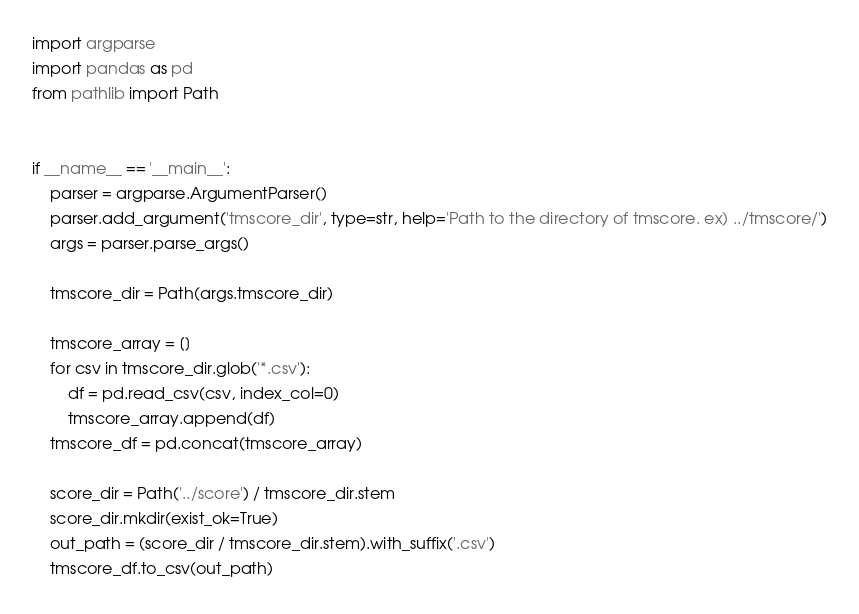Convert code to text. <code><loc_0><loc_0><loc_500><loc_500><_Python_>import argparse
import pandas as pd
from pathlib import Path


if __name__ == '__main__':
    parser = argparse.ArgumentParser()
    parser.add_argument('tmscore_dir', type=str, help='Path to the directory of tmscore. ex) ../tmscore/')
    args = parser.parse_args()
    
    tmscore_dir = Path(args.tmscore_dir)

    tmscore_array = []
    for csv in tmscore_dir.glob('*.csv'):
        df = pd.read_csv(csv, index_col=0)
        tmscore_array.append(df)
    tmscore_df = pd.concat(tmscore_array)

    score_dir = Path('../score') / tmscore_dir.stem
    score_dir.mkdir(exist_ok=True)
    out_path = (score_dir / tmscore_dir.stem).with_suffix('.csv')
    tmscore_df.to_csv(out_path)
</code> 